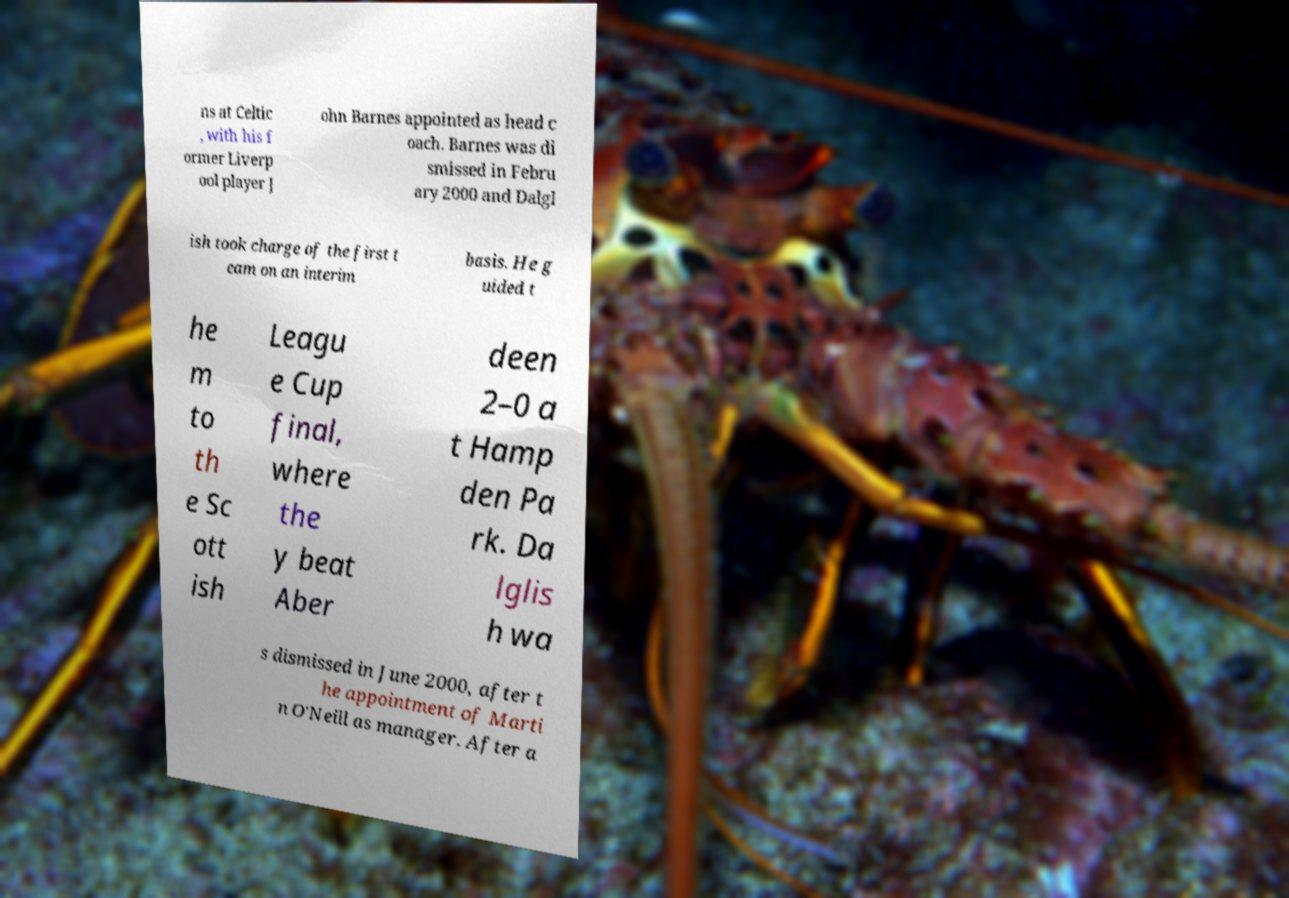Please identify and transcribe the text found in this image. ns at Celtic , with his f ormer Liverp ool player J ohn Barnes appointed as head c oach. Barnes was di smissed in Febru ary 2000 and Dalgl ish took charge of the first t eam on an interim basis. He g uided t he m to th e Sc ott ish Leagu e Cup final, where the y beat Aber deen 2–0 a t Hamp den Pa rk. Da lglis h wa s dismissed in June 2000, after t he appointment of Marti n O'Neill as manager. After a 